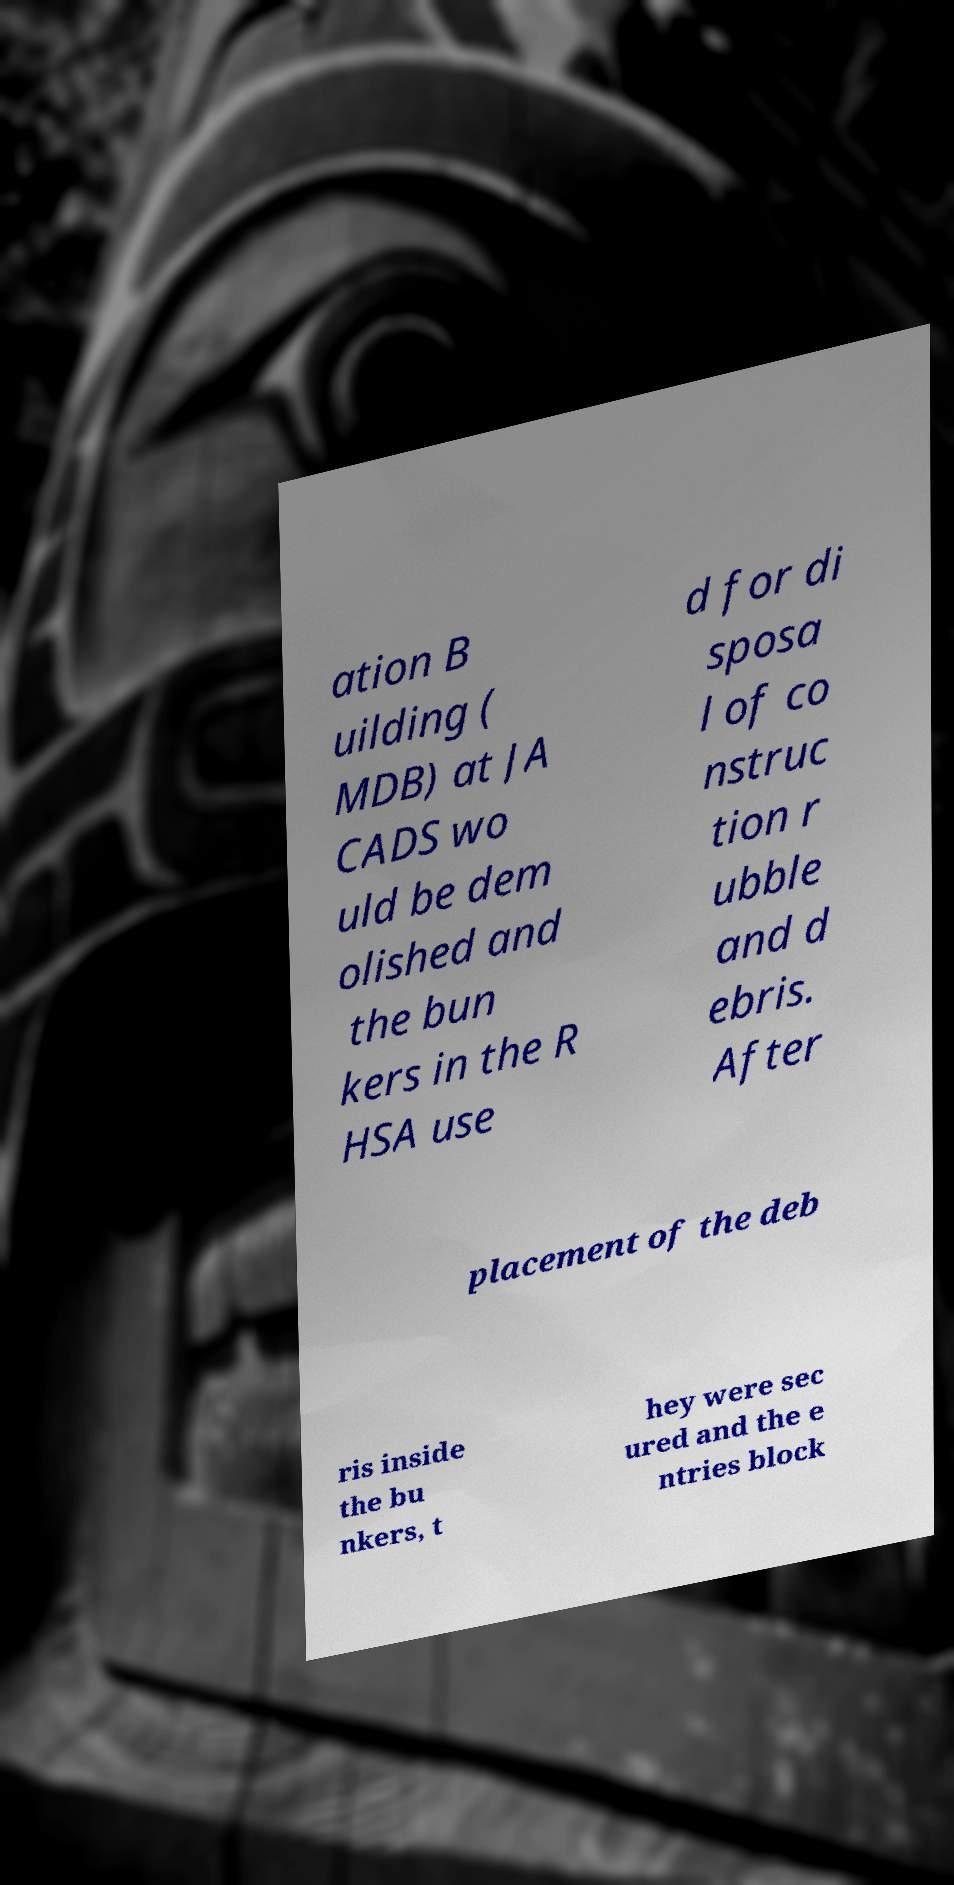Could you extract and type out the text from this image? ation B uilding ( MDB) at JA CADS wo uld be dem olished and the bun kers in the R HSA use d for di sposa l of co nstruc tion r ubble and d ebris. After placement of the deb ris inside the bu nkers, t hey were sec ured and the e ntries block 